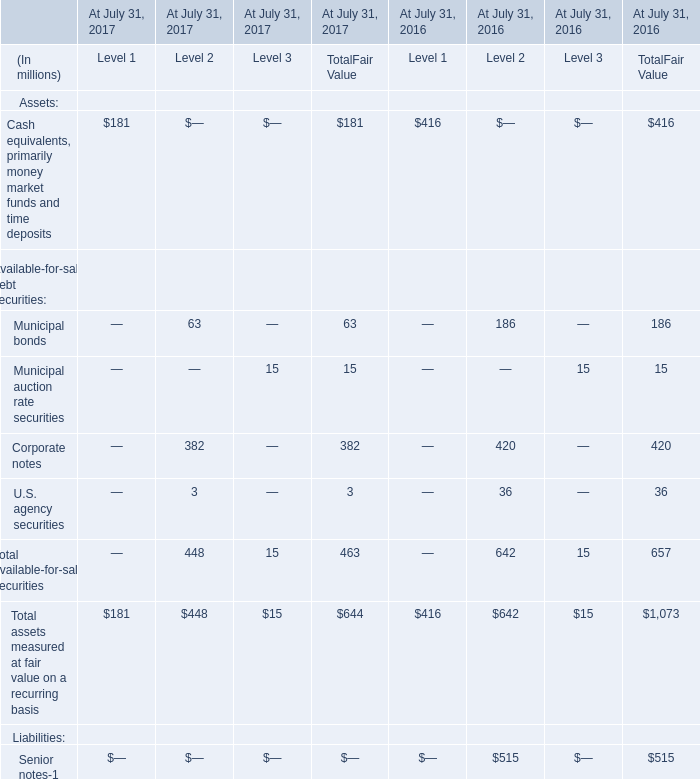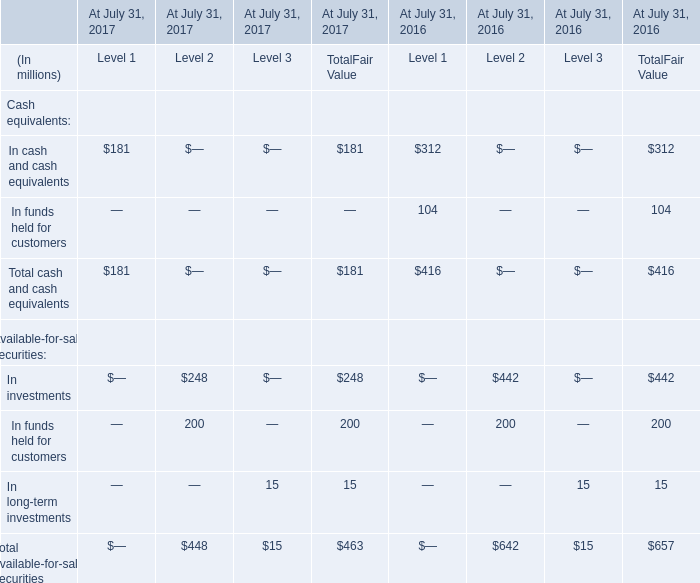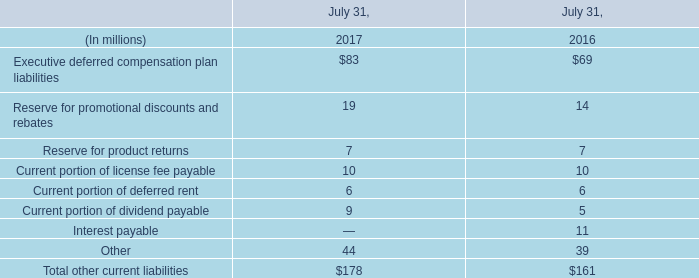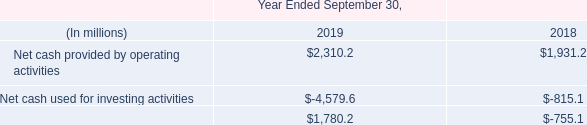What's the greatest value of Municipal auction rate securities in 2017 for Assets? (in million) 
Answer: 15. 